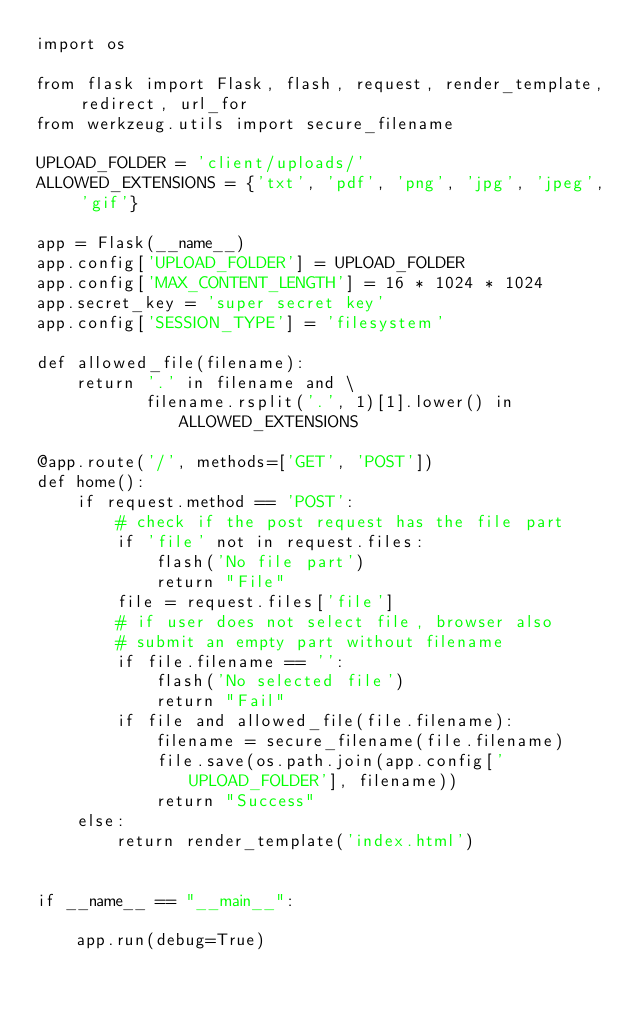Convert code to text. <code><loc_0><loc_0><loc_500><loc_500><_Python_>import os

from flask import Flask, flash, request, render_template, redirect, url_for
from werkzeug.utils import secure_filename

UPLOAD_FOLDER = 'client/uploads/'
ALLOWED_EXTENSIONS = {'txt', 'pdf', 'png', 'jpg', 'jpeg', 'gif'}

app = Flask(__name__)
app.config['UPLOAD_FOLDER'] = UPLOAD_FOLDER
app.config['MAX_CONTENT_LENGTH'] = 16 * 1024 * 1024
app.secret_key = 'super secret key'
app.config['SESSION_TYPE'] = 'filesystem'

def allowed_file(filename):
    return '.' in filename and \
           filename.rsplit('.', 1)[1].lower() in ALLOWED_EXTENSIONS

@app.route('/', methods=['GET', 'POST'])
def home():
    if request.method == 'POST':
        # check if the post request has the file part
        if 'file' not in request.files:
            flash('No file part')
            return "File"
        file = request.files['file']
        # if user does not select file, browser also
        # submit an empty part without filename
        if file.filename == '':
            flash('No selected file')
            return "Fail"
        if file and allowed_file(file.filename):
            filename = secure_filename(file.filename)
            file.save(os.path.join(app.config['UPLOAD_FOLDER'], filename))
            return "Success"
    else:
        return render_template('index.html')


if __name__ == "__main__":

    app.run(debug=True)
</code> 